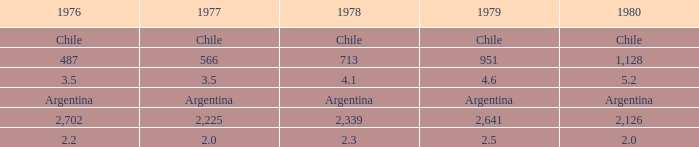What is 1980 when 1978 is 2.3? 2.0. 